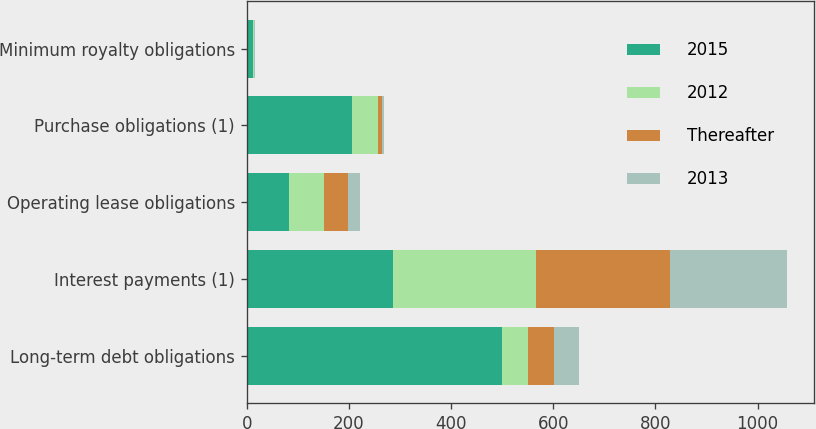Convert chart. <chart><loc_0><loc_0><loc_500><loc_500><stacked_bar_chart><ecel><fcel>Long-term debt obligations<fcel>Interest payments (1)<fcel>Operating lease obligations<fcel>Purchase obligations (1)<fcel>Minimum royalty obligations<nl><fcel>2015<fcel>500<fcel>286<fcel>83<fcel>205<fcel>13<nl><fcel>2012<fcel>50<fcel>280<fcel>69<fcel>51<fcel>1<nl><fcel>Thereafter<fcel>50.5<fcel>262<fcel>46<fcel>8<fcel>1<nl><fcel>2013<fcel>50.5<fcel>229<fcel>24<fcel>4<fcel>1<nl></chart> 